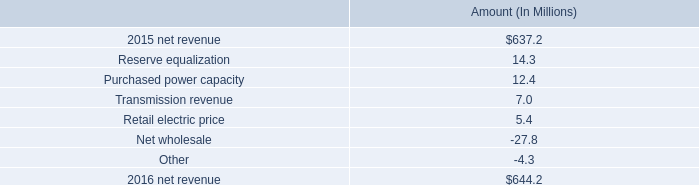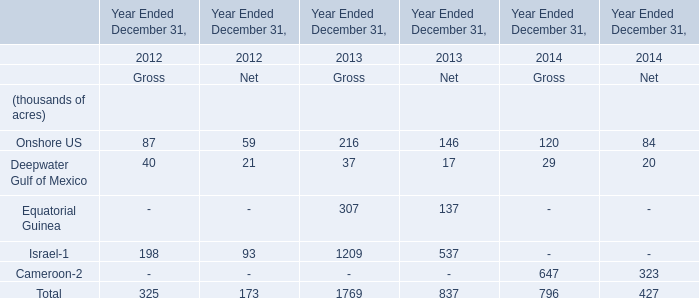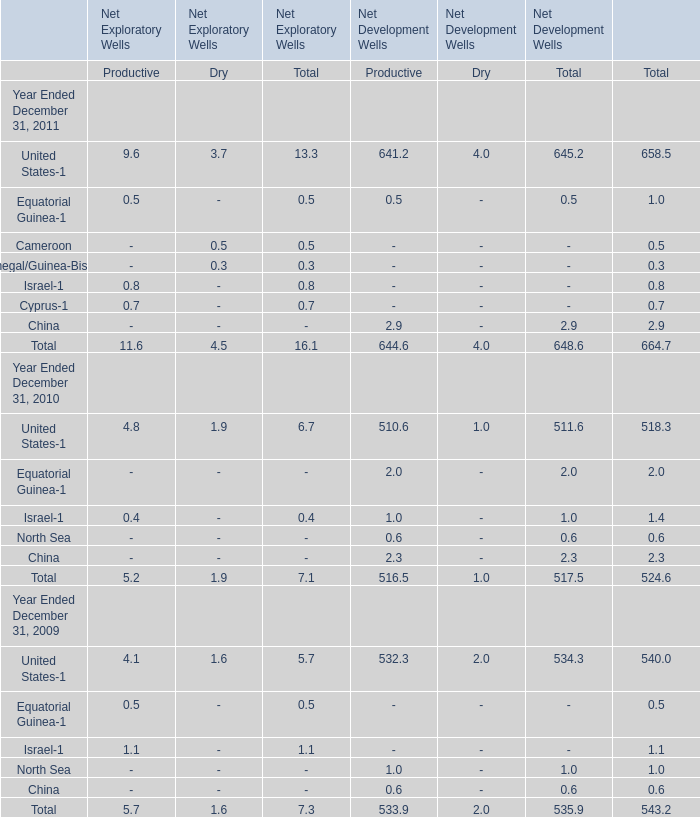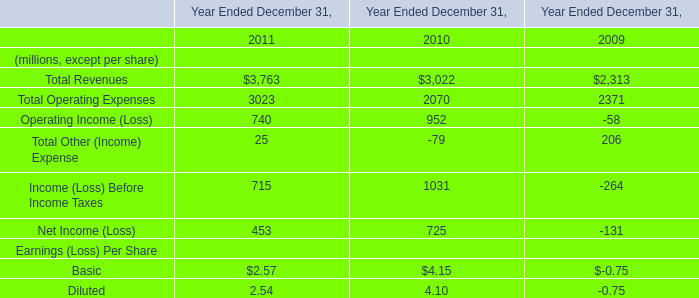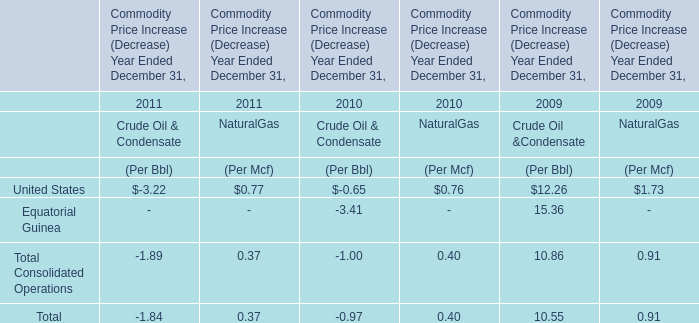in millions , what is the total impact on the change in net revenue from the reserve equalization , the purchased power capacity , and the transmission revenue? 
Computations: ((14.3 + 12.4) + 7)
Answer: 33.7. 